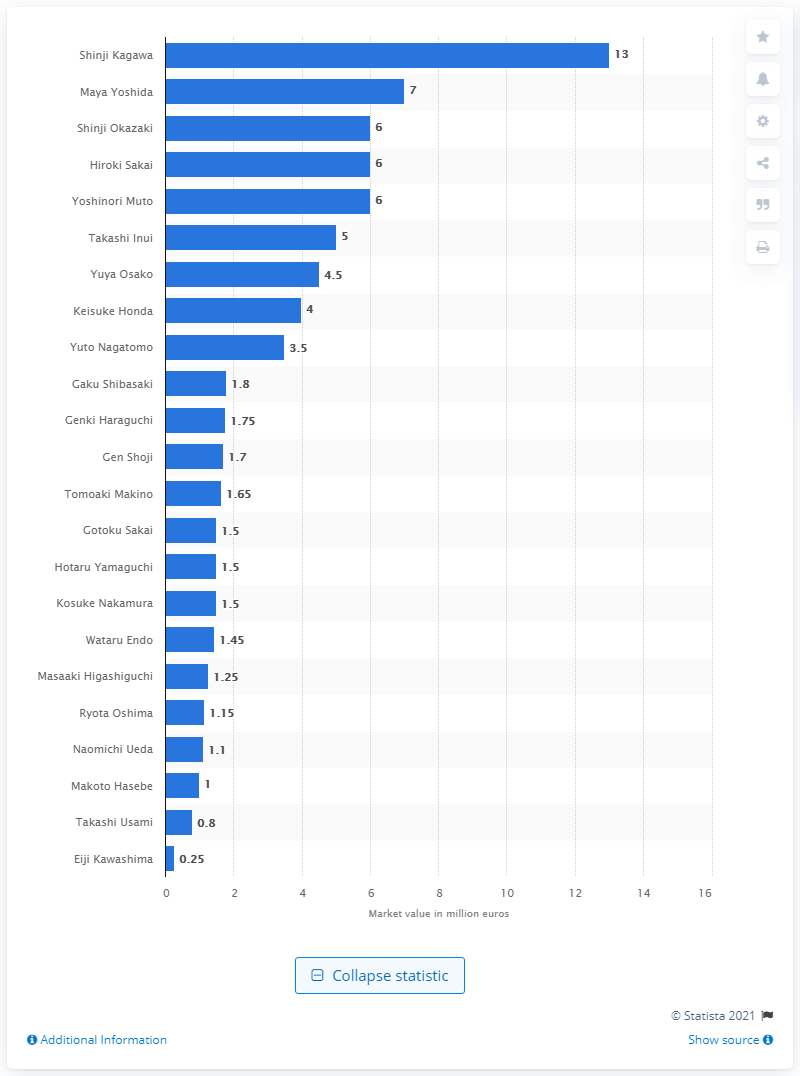Mention a couple of crucial points in this snapshot. At the 2018 FIFA World Cup, Shinji Kagawa was considered the most valuable player. 